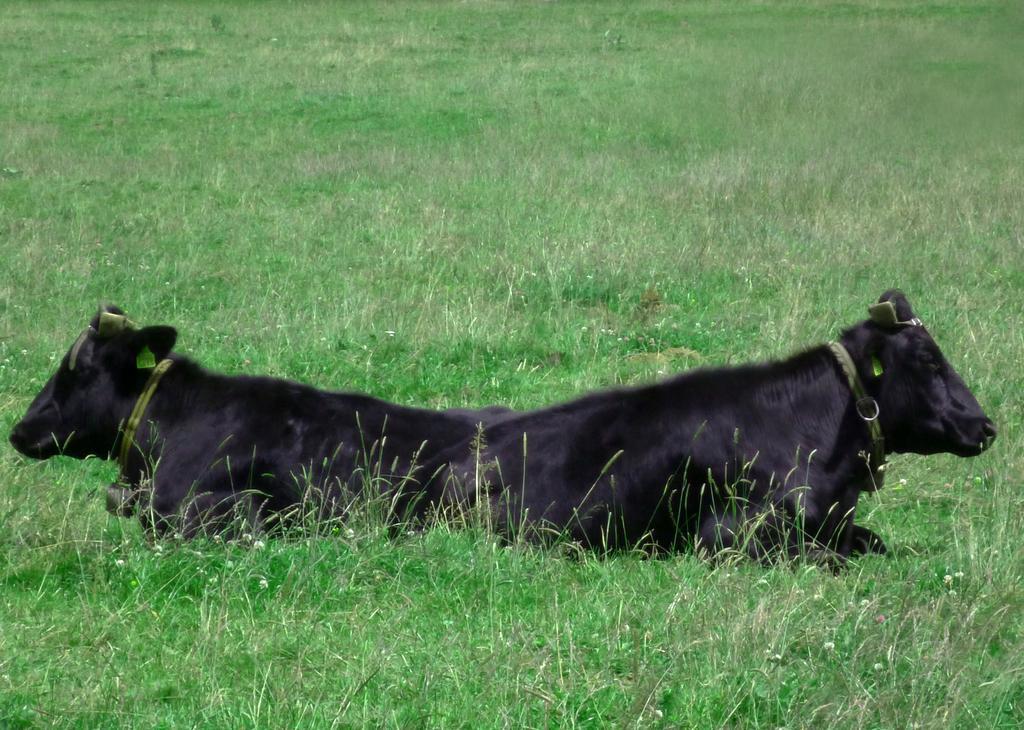Could you give a brief overview of what you see in this image? In the foreground of this picture, there are two buffaloes sitting on the grass. 